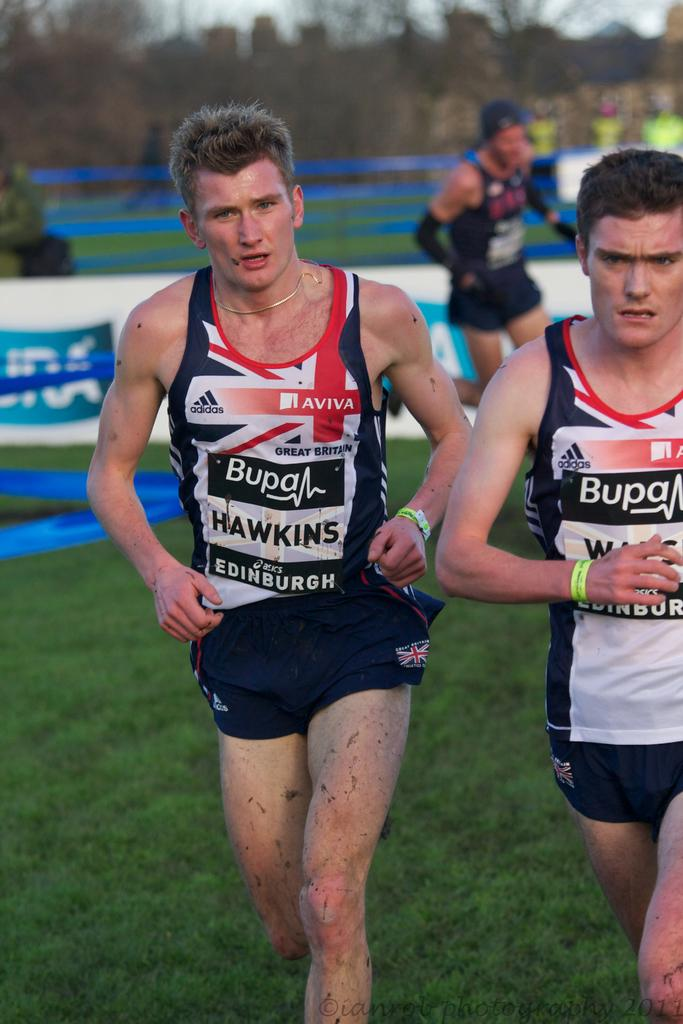<image>
Render a clear and concise summary of the photo. Runners wear tank tops that were made by adidas. 